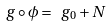<formula> <loc_0><loc_0><loc_500><loc_500>\ g \circ \phi = \ g _ { 0 } + N</formula> 